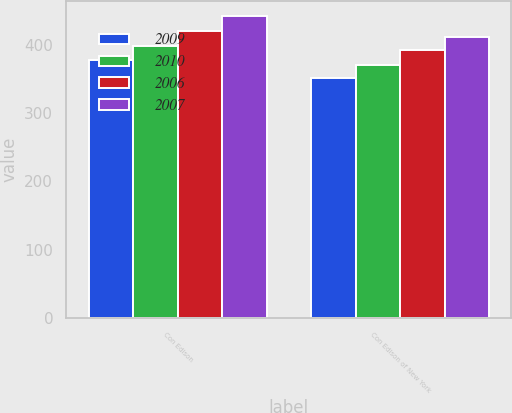<chart> <loc_0><loc_0><loc_500><loc_500><stacked_bar_chart><ecel><fcel>Con Edison<fcel>Con Edison of New York<nl><fcel>2009<fcel>378<fcel>351<nl><fcel>2010<fcel>399<fcel>371<nl><fcel>2006<fcel>421<fcel>392<nl><fcel>2007<fcel>442<fcel>412<nl></chart> 